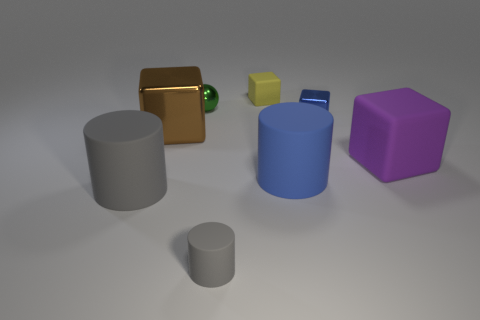Subtract 1 cubes. How many cubes are left? 3 Subtract all purple cubes. Subtract all gray balls. How many cubes are left? 3 Add 1 metallic cylinders. How many objects exist? 9 Subtract all spheres. How many objects are left? 7 Subtract 0 gray balls. How many objects are left? 8 Subtract all small matte things. Subtract all purple balls. How many objects are left? 6 Add 1 green balls. How many green balls are left? 2 Add 1 tiny cyan metallic blocks. How many tiny cyan metallic blocks exist? 1 